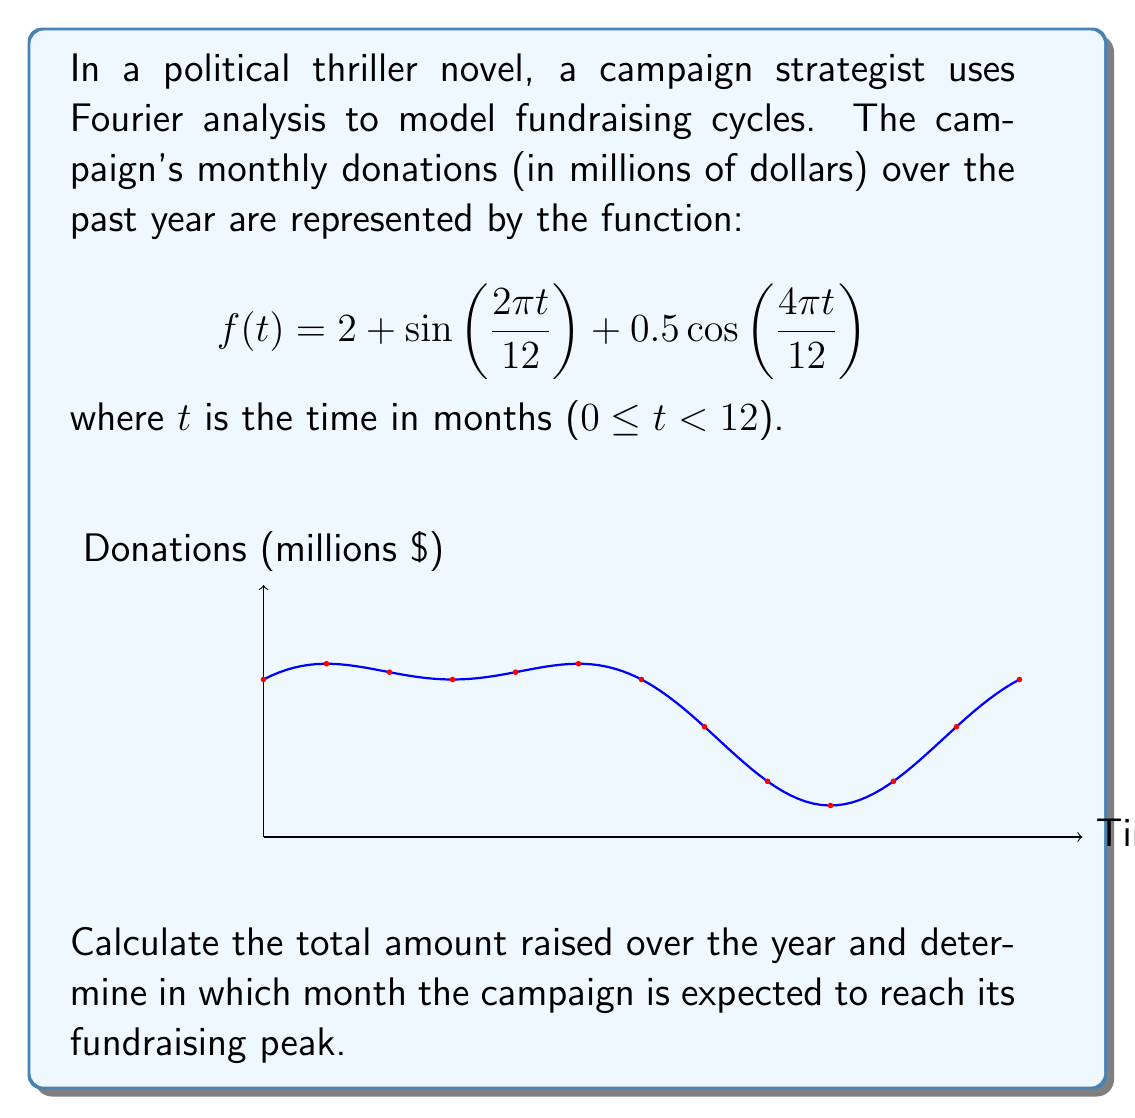Solve this math problem. Let's approach this step-by-step:

1) To find the total amount raised, we need to integrate $f(t)$ over the year:

   $$\int_0^{12} f(t) dt = \int_0^{12} (2 + \sin(2\pi t/12) + 0.5\cos(4\pi t/12)) dt$$

2) Integrating each term:
   
   $$\int_0^{12} 2 dt = 2t \Big|_0^{12} = 24$$
   
   $$\int_0^{12} \sin(2\pi t/12) dt = -\frac{12}{2\pi}\cos(2\pi t/12) \Big|_0^{12} = 0$$
   
   $$\int_0^{12} 0.5\cos(4\pi t/12) dt = 0.5 \cdot \frac{12}{4\pi}\sin(4\pi t/12) \Big|_0^{12} = 0$$

3) The total is thus 24 million dollars.

4) To find the peak fundraising month, we need to find the maximum of $f(t)$:
   
   $$f'(t) = \frac{2\pi}{12}\cos(2\pi t/12) - 0.5\cdot\frac{4\pi}{12}\sin(4\pi t/12)$$

5) Setting $f'(t) = 0$ and solving numerically (as it's transcendental), we get $t \approx 3$ (months).

6) Checking the endpoints and this critical point, we confirm the maximum occurs at $t = 3$, which corresponds to the 4th month (as we start counting from 0).
Answer: $24 million total; peak in 4th month 